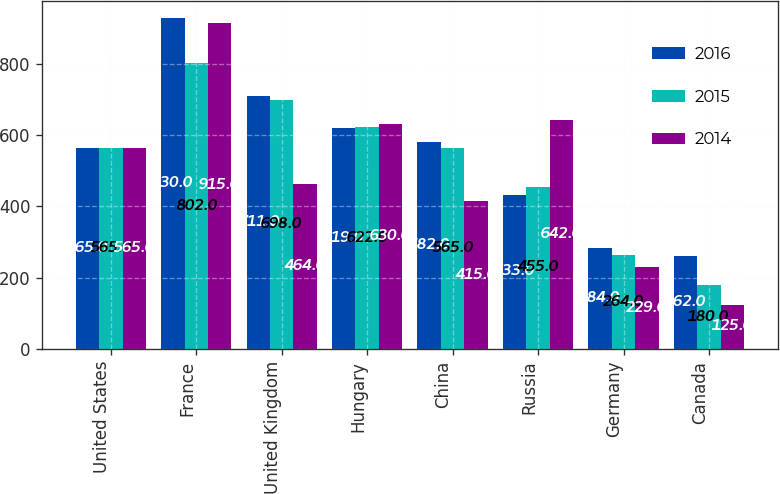Convert chart to OTSL. <chart><loc_0><loc_0><loc_500><loc_500><stacked_bar_chart><ecel><fcel>United States<fcel>France<fcel>United Kingdom<fcel>Hungary<fcel>China<fcel>Russia<fcel>Germany<fcel>Canada<nl><fcel>2016<fcel>565<fcel>930<fcel>711<fcel>619<fcel>582<fcel>433<fcel>284<fcel>262<nl><fcel>2015<fcel>565<fcel>802<fcel>698<fcel>622<fcel>565<fcel>455<fcel>264<fcel>180<nl><fcel>2014<fcel>565<fcel>915<fcel>464<fcel>630<fcel>415<fcel>642<fcel>229<fcel>125<nl></chart> 